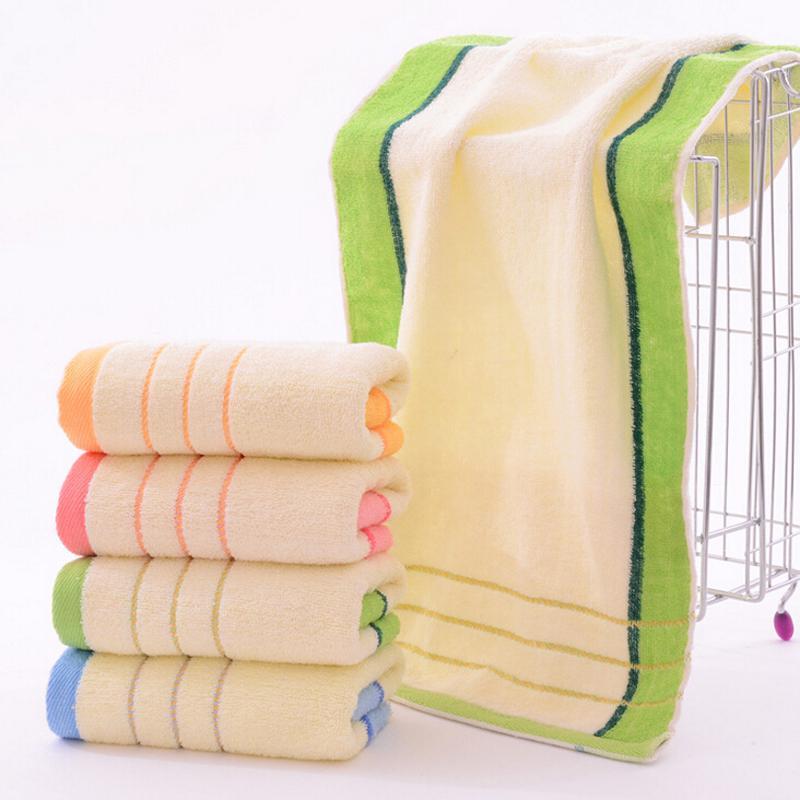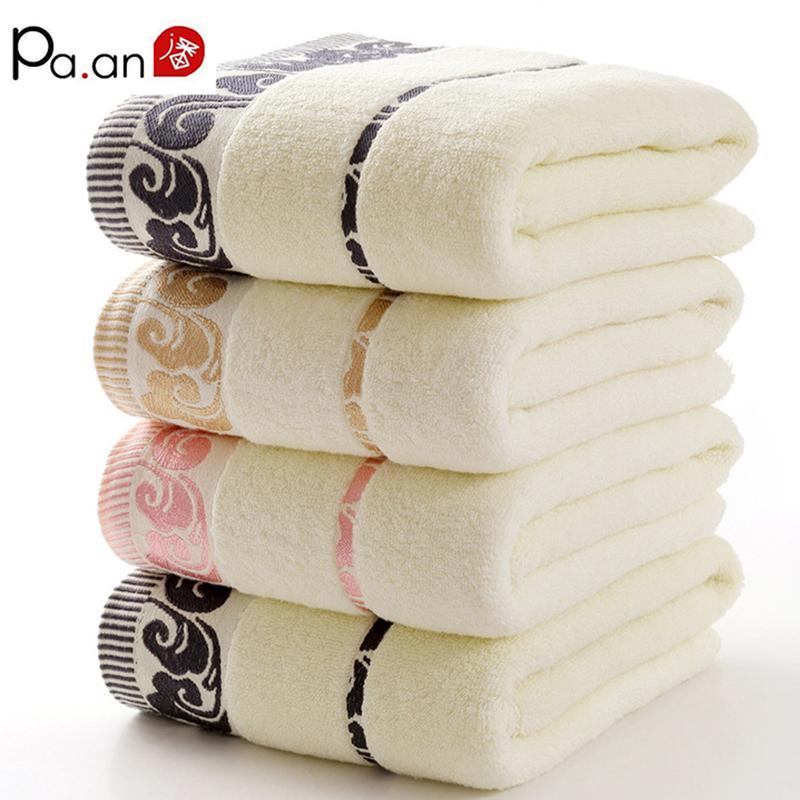The first image is the image on the left, the second image is the image on the right. Analyze the images presented: Is the assertion "There is at least part of a toilet shown." valid? Answer yes or no. No. 